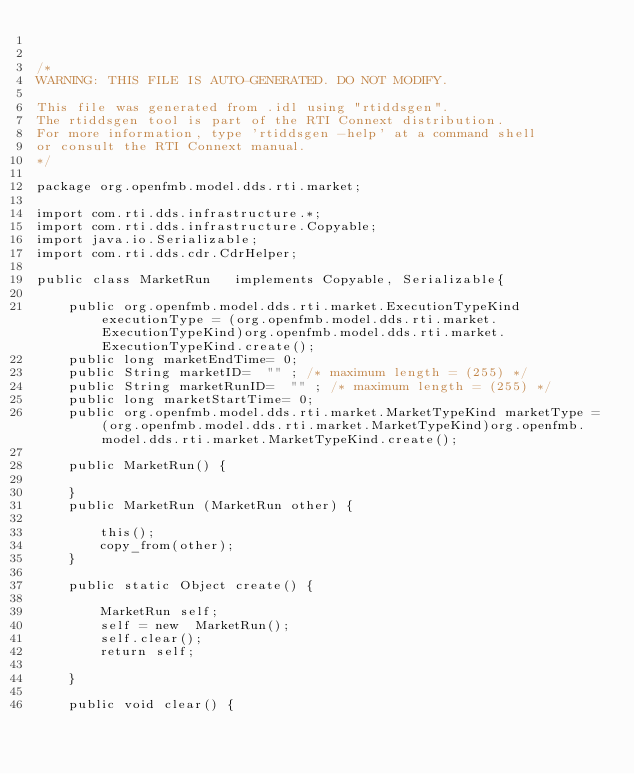<code> <loc_0><loc_0><loc_500><loc_500><_Java_>

/*
WARNING: THIS FILE IS AUTO-GENERATED. DO NOT MODIFY.

This file was generated from .idl using "rtiddsgen".
The rtiddsgen tool is part of the RTI Connext distribution.
For more information, type 'rtiddsgen -help' at a command shell
or consult the RTI Connext manual.
*/

package org.openfmb.model.dds.rti.market;

import com.rti.dds.infrastructure.*;
import com.rti.dds.infrastructure.Copyable;
import java.io.Serializable;
import com.rti.dds.cdr.CdrHelper;

public class MarketRun   implements Copyable, Serializable{

    public org.openfmb.model.dds.rti.market.ExecutionTypeKind executionType = (org.openfmb.model.dds.rti.market.ExecutionTypeKind)org.openfmb.model.dds.rti.market.ExecutionTypeKind.create();
    public long marketEndTime= 0;
    public String marketID=  "" ; /* maximum length = (255) */
    public String marketRunID=  "" ; /* maximum length = (255) */
    public long marketStartTime= 0;
    public org.openfmb.model.dds.rti.market.MarketTypeKind marketType = (org.openfmb.model.dds.rti.market.MarketTypeKind)org.openfmb.model.dds.rti.market.MarketTypeKind.create();

    public MarketRun() {

    }
    public MarketRun (MarketRun other) {

        this();
        copy_from(other);
    }

    public static Object create() {

        MarketRun self;
        self = new  MarketRun();
        self.clear();
        return self;

    }

    public void clear() {
</code> 